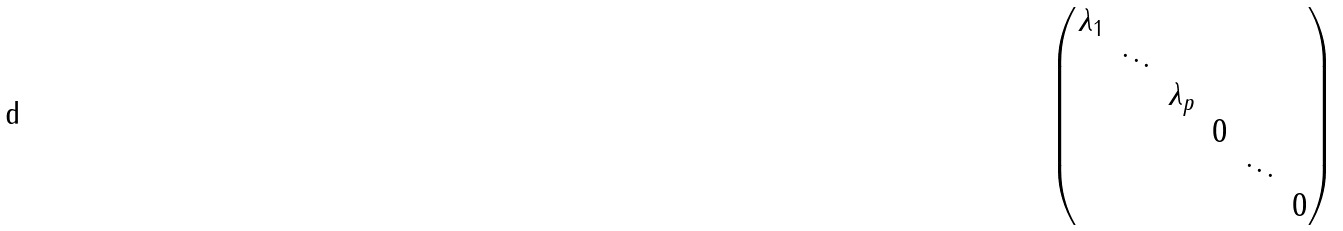<formula> <loc_0><loc_0><loc_500><loc_500>\begin{pmatrix} \lambda _ { 1 } \\ & \ddots \\ & & \lambda _ { p } \\ & & & 0 \\ & & & & \ddots \\ & & & & & 0 \end{pmatrix}</formula> 